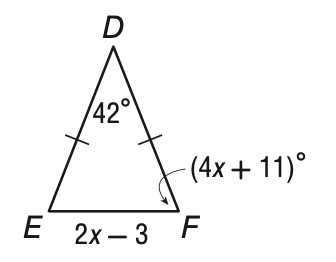Question: What is the length of E F?
Choices:
A. 13
B. 14.5
C. 26
D. 29
Answer with the letter. Answer: C 